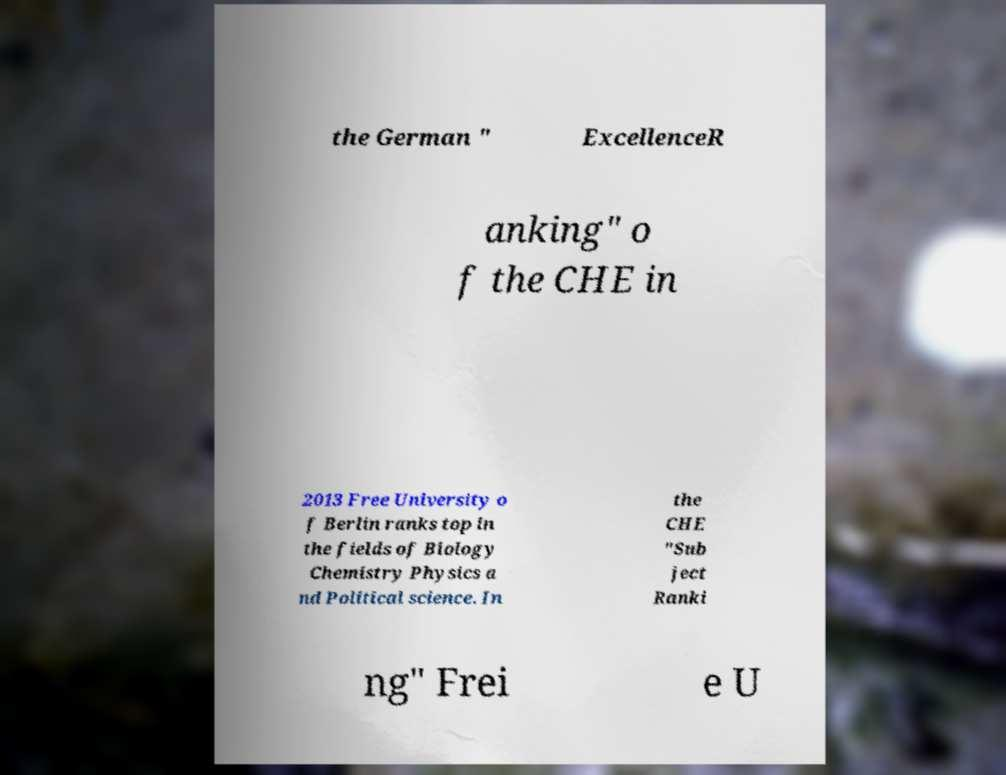For documentation purposes, I need the text within this image transcribed. Could you provide that? the German " ExcellenceR anking" o f the CHE in 2013 Free University o f Berlin ranks top in the fields of Biology Chemistry Physics a nd Political science. In the CHE "Sub ject Ranki ng" Frei e U 